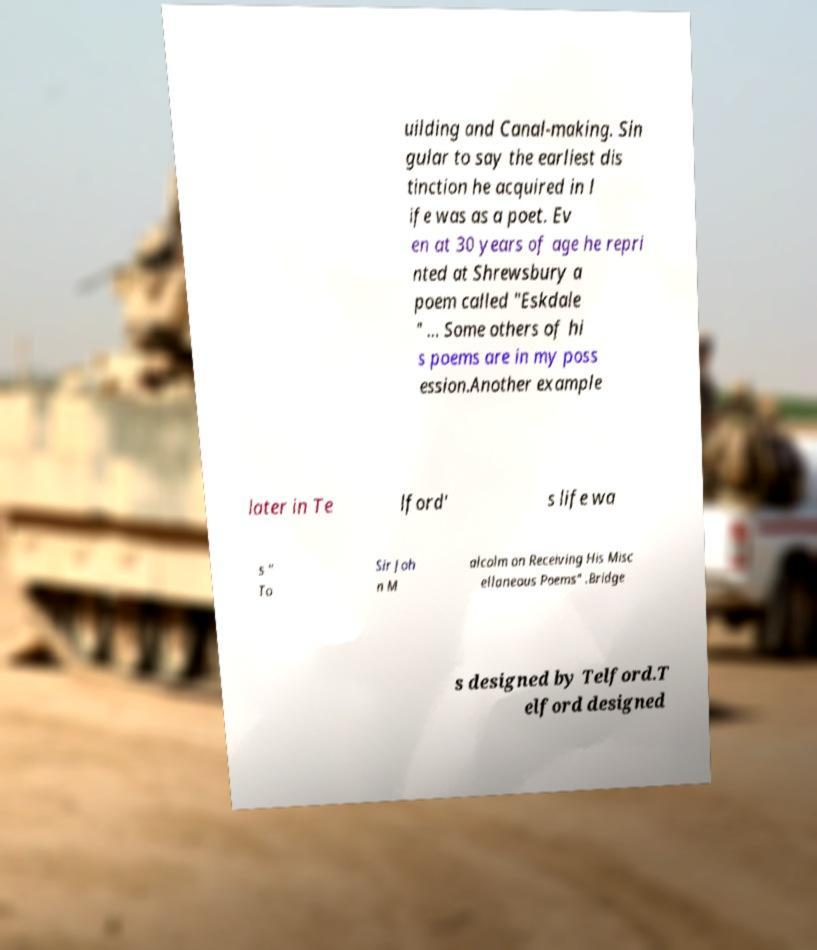For documentation purposes, I need the text within this image transcribed. Could you provide that? uilding and Canal-making. Sin gular to say the earliest dis tinction he acquired in l ife was as a poet. Ev en at 30 years of age he repri nted at Shrewsbury a poem called "Eskdale " … Some others of hi s poems are in my poss ession.Another example later in Te lford' s life wa s " To Sir Joh n M alcolm on Receiving His Misc ellaneous Poems" .Bridge s designed by Telford.T elford designed 